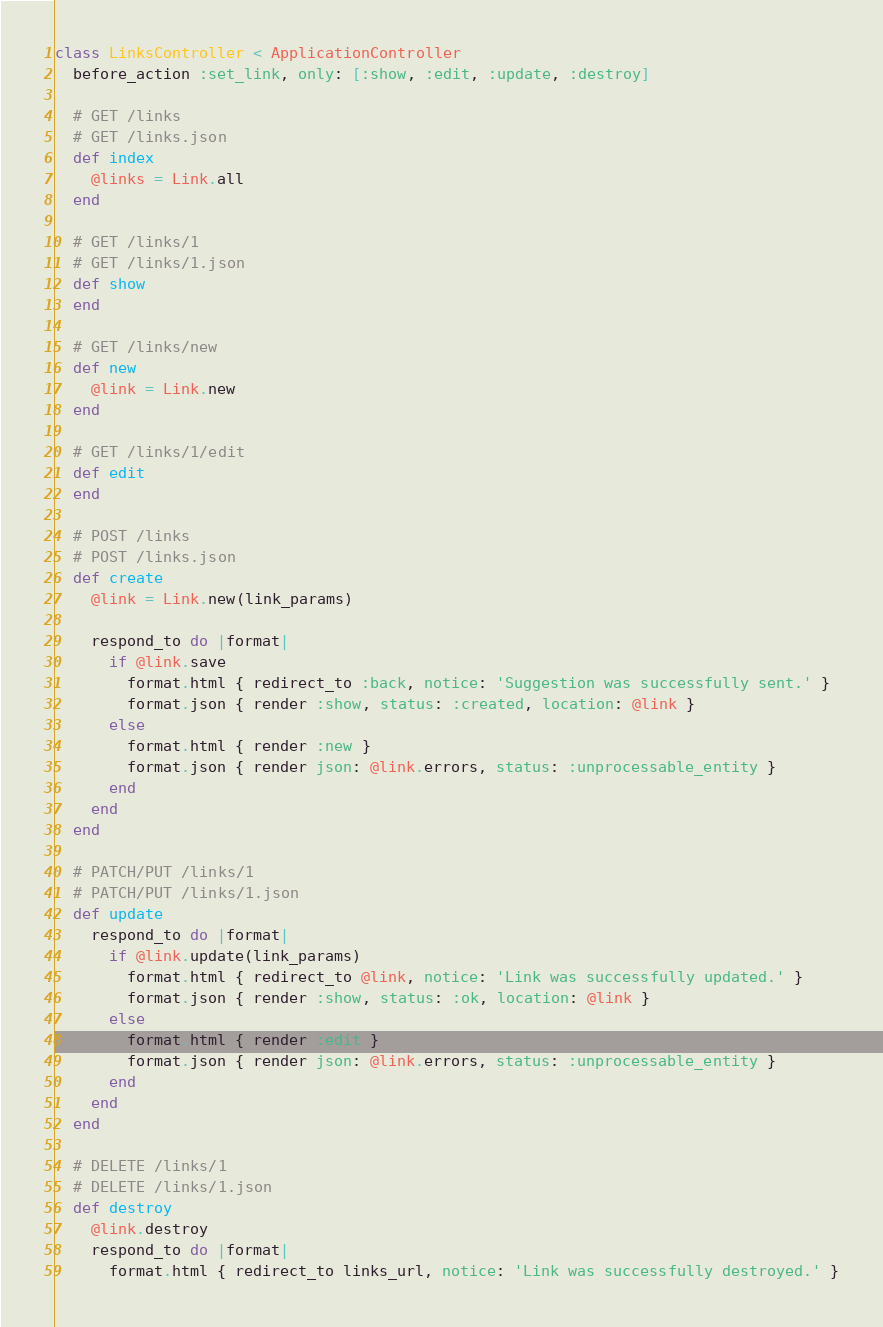<code> <loc_0><loc_0><loc_500><loc_500><_Ruby_>class LinksController < ApplicationController
  before_action :set_link, only: [:show, :edit, :update, :destroy]

  # GET /links
  # GET /links.json
  def index
    @links = Link.all
  end

  # GET /links/1
  # GET /links/1.json
  def show
  end

  # GET /links/new
  def new
    @link = Link.new
  end

  # GET /links/1/edit
  def edit
  end

  # POST /links
  # POST /links.json
  def create
    @link = Link.new(link_params)

    respond_to do |format|
      if @link.save
        format.html { redirect_to :back, notice: 'Suggestion was successfully sent.' }
        format.json { render :show, status: :created, location: @link }
      else
        format.html { render :new }
        format.json { render json: @link.errors, status: :unprocessable_entity }
      end
    end
  end

  # PATCH/PUT /links/1
  # PATCH/PUT /links/1.json
  def update
    respond_to do |format|
      if @link.update(link_params)
        format.html { redirect_to @link, notice: 'Link was successfully updated.' }
        format.json { render :show, status: :ok, location: @link }
      else
        format.html { render :edit }
        format.json { render json: @link.errors, status: :unprocessable_entity }
      end
    end
  end

  # DELETE /links/1
  # DELETE /links/1.json
  def destroy
    @link.destroy
    respond_to do |format|
      format.html { redirect_to links_url, notice: 'Link was successfully destroyed.' }</code> 